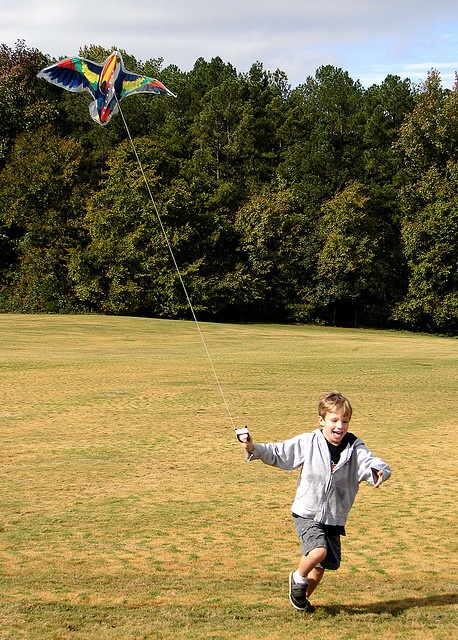Describe the objects in this image and their specific colors. I can see people in lavender, white, gray, black, and darkgray tones and kite in lavender, black, darkgray, navy, and gray tones in this image. 